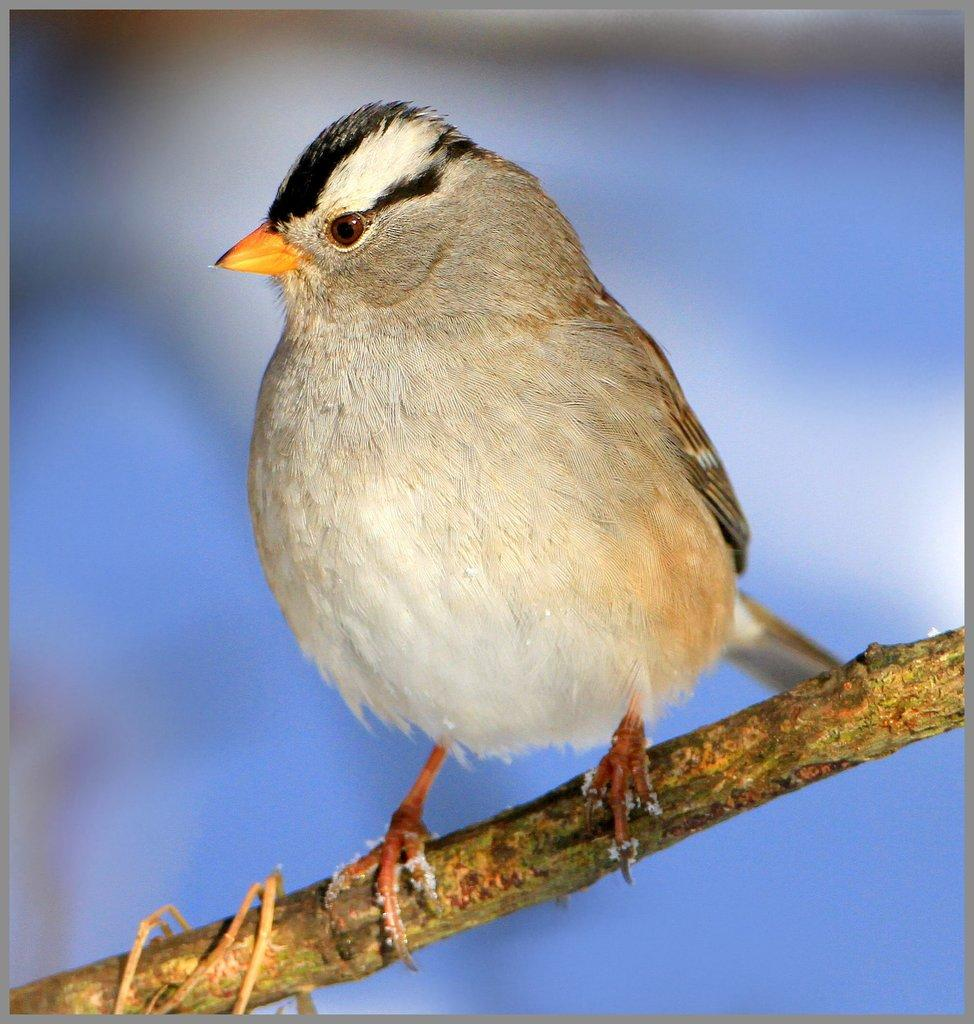What type of animal can be seen in the image? There is a bird in the image. Where is the bird located? The bird is standing on a tree branch. Can you describe the background of the image? The background of the image is blurry. What type of note is the bird holding in its beak in the image? There is no note present in the image; the bird is standing on a tree branch without holding anything. 